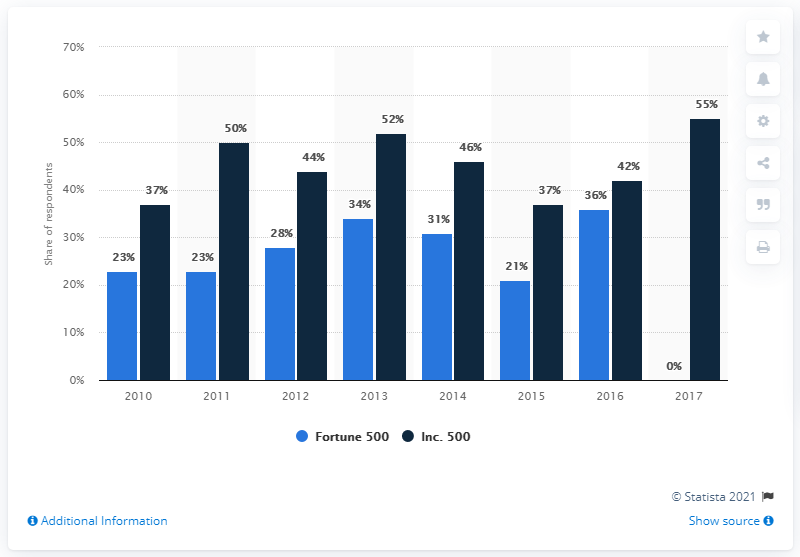Indicate a few pertinent items in this graphic. The highest dark blue bar has a value of 55. The sum of the highest and lowest values of the dark blue bar is 92. 